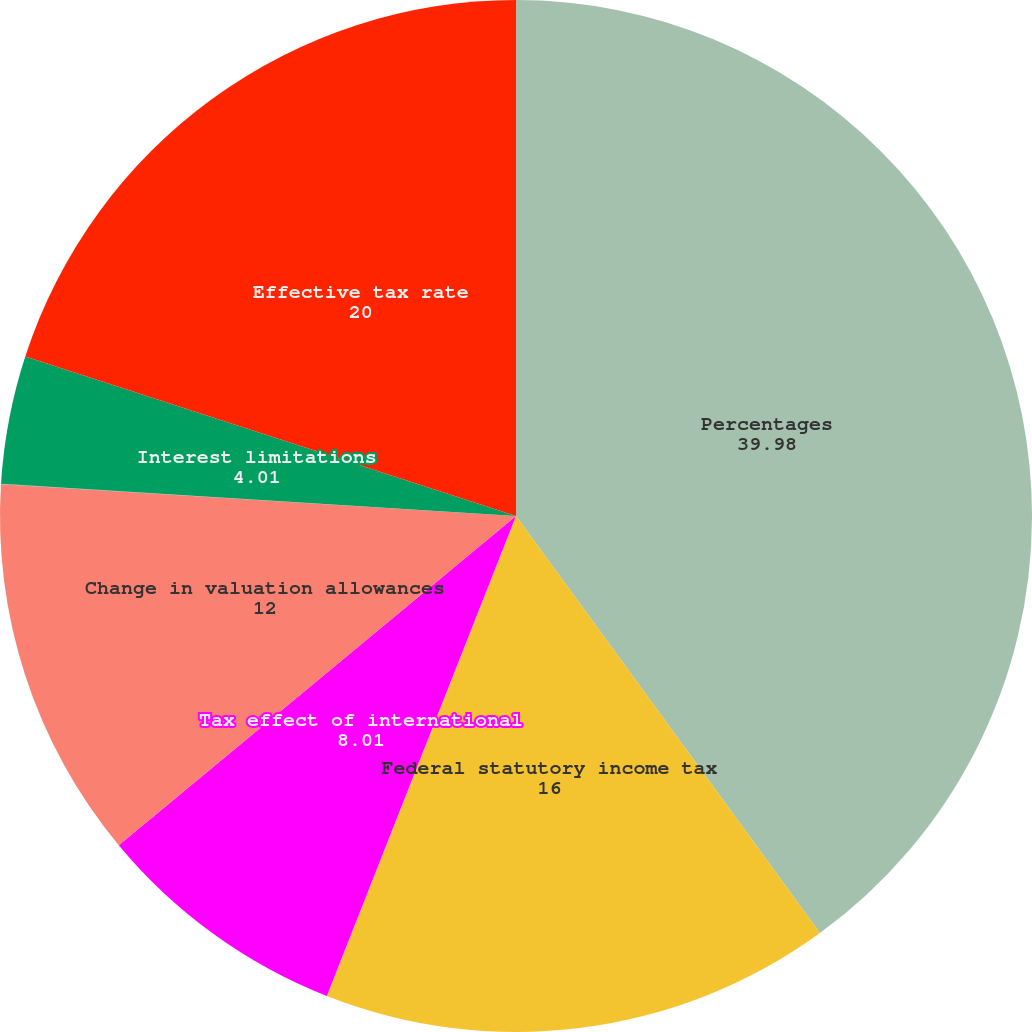Convert chart. <chart><loc_0><loc_0><loc_500><loc_500><pie_chart><fcel>Percentages<fcel>Federal statutory income tax<fcel>Tax effect of international<fcel>Change in valuation allowances<fcel>Withholding taxes<fcel>Interest limitations<fcel>Effective tax rate<nl><fcel>39.98%<fcel>16.0%<fcel>8.01%<fcel>12.0%<fcel>0.01%<fcel>4.01%<fcel>20.0%<nl></chart> 